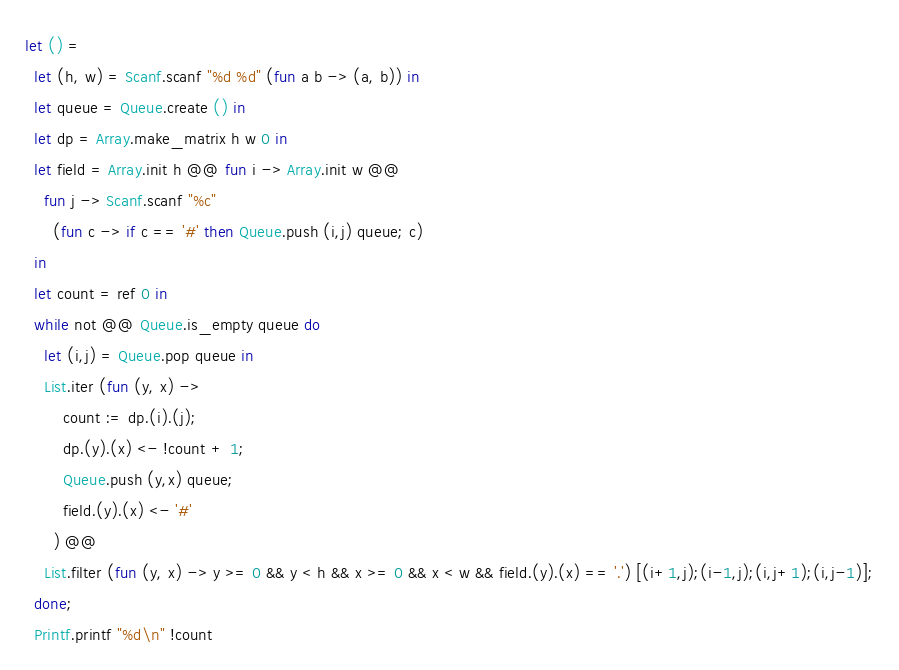Convert code to text. <code><loc_0><loc_0><loc_500><loc_500><_OCaml_>let () =
  let (h, w) = Scanf.scanf "%d %d" (fun a b -> (a, b)) in
  let queue = Queue.create () in
  let dp = Array.make_matrix h w 0 in
  let field = Array.init h @@ fun i -> Array.init w @@
    fun j -> Scanf.scanf "%c"
      (fun c -> if c == '#' then Queue.push (i,j) queue; c)
  in
  let count = ref 0 in
  while not @@ Queue.is_empty queue do
    let (i,j) = Queue.pop queue in
    List.iter (fun (y, x) ->
        count := dp.(i).(j);
        dp.(y).(x) <- !count + 1;
        Queue.push (y,x) queue;
        field.(y).(x) <- '#'
      ) @@
    List.filter (fun (y, x) -> y >= 0 && y < h && x >= 0 && x < w && field.(y).(x) == '.') [(i+1,j);(i-1,j);(i,j+1);(i,j-1)];
  done;
  Printf.printf "%d\n" !count</code> 